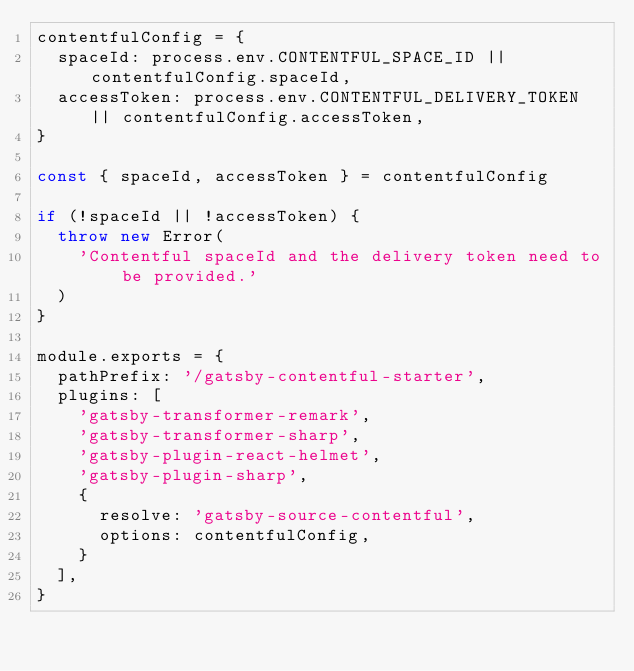Convert code to text. <code><loc_0><loc_0><loc_500><loc_500><_JavaScript_>contentfulConfig = {
  spaceId: process.env.CONTENTFUL_SPACE_ID || contentfulConfig.spaceId,
  accessToken: process.env.CONTENTFUL_DELIVERY_TOKEN || contentfulConfig.accessToken,
}

const { spaceId, accessToken } = contentfulConfig

if (!spaceId || !accessToken) {
  throw new Error(
    'Contentful spaceId and the delivery token need to be provided.'
  )
}

module.exports = {
  pathPrefix: '/gatsby-contentful-starter',
  plugins: [
    'gatsby-transformer-remark',
    'gatsby-transformer-sharp',
    'gatsby-plugin-react-helmet',
    'gatsby-plugin-sharp',
    {
      resolve: 'gatsby-source-contentful',
      options: contentfulConfig,
    }
  ],
}
</code> 